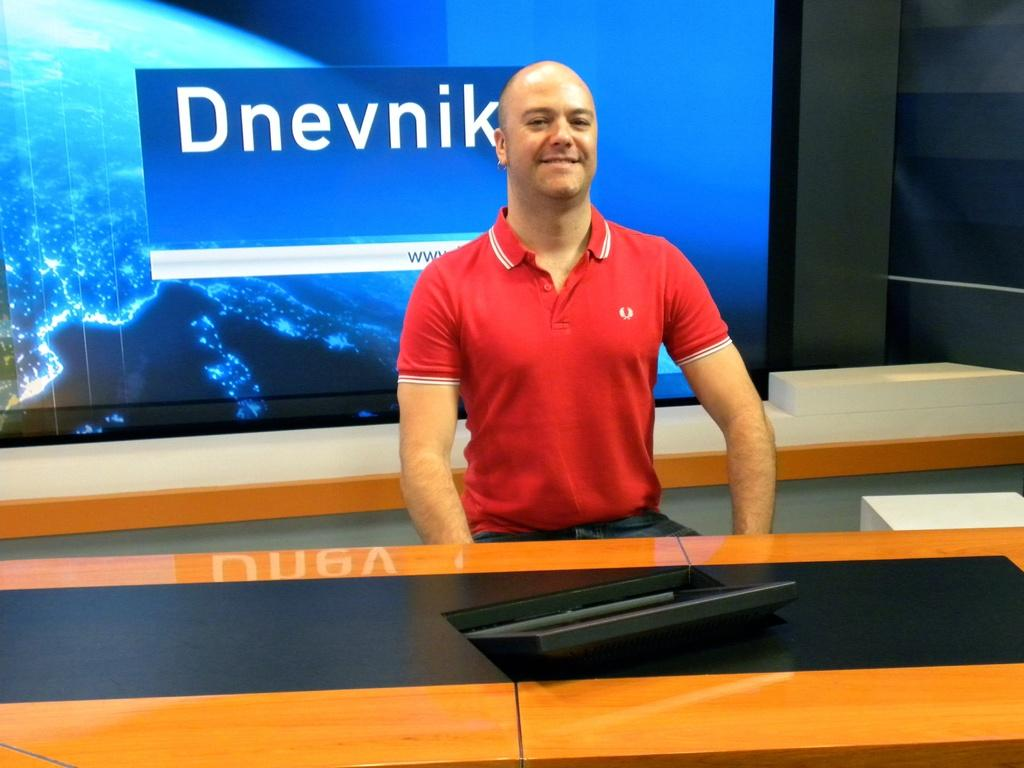<image>
Create a compact narrative representing the image presented. A man in a red shirt is in front of a sign with Dnevnik behind him. 